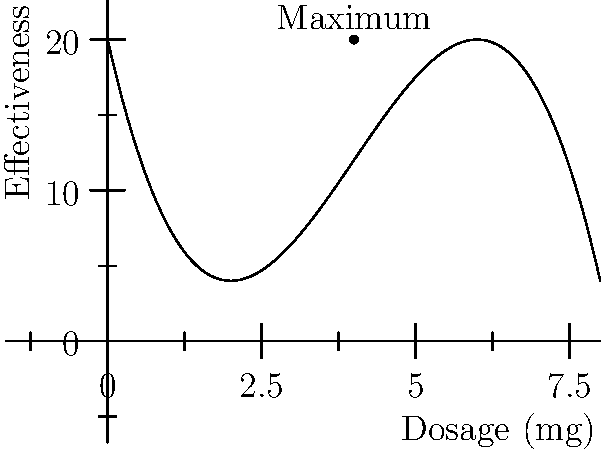As a data scientist analyzing the impact of biotechnologies on healthcare outcomes, you're studying the effectiveness of a new drug treatment. The effectiveness $E$ of the treatment as a function of dosage $x$ (in mg) is given by:

$$E(x) = -0.5x^3 + 6x^2 - 18x + 20$$

Find the optimal dosage that maximizes the treatment's effectiveness and calculate the maximum effectiveness achieved. To find the optimal dosage, we need to find the critical points of the function $E(x)$ and determine which one maximizes the effectiveness.

1. Find the derivative of $E(x)$:
   $$E'(x) = -1.5x^2 + 12x - 18$$

2. Set $E'(x) = 0$ and solve for x:
   $$-1.5x^2 + 12x - 18 = 0$$
   $$-3x^2 + 24x - 36 = 0$$
   $$-3(x^2 - 8x + 12) = 0$$
   $$-3(x - 6)(x - 2) = 0$$
   $$x = 6 \text{ or } x = 2$$

3. Calculate the second derivative to determine the nature of these critical points:
   $$E''(x) = -3x + 12$$
   At $x = 2$: $E''(2) = 6 > 0$, so this is a local minimum.
   At $x = 6$: $E''(6) = -6 < 0$, so this is a local maximum.

4. Calculate the effectiveness at $x = 6$:
   $$E(6) = -0.5(6)^3 + 6(6)^2 - 18(6) + 20 = 20$$

Therefore, the optimal dosage is 6 mg, which yields a maximum effectiveness of 20 units.
Answer: Optimal dosage: 6 mg; Maximum effectiveness: 20 units 